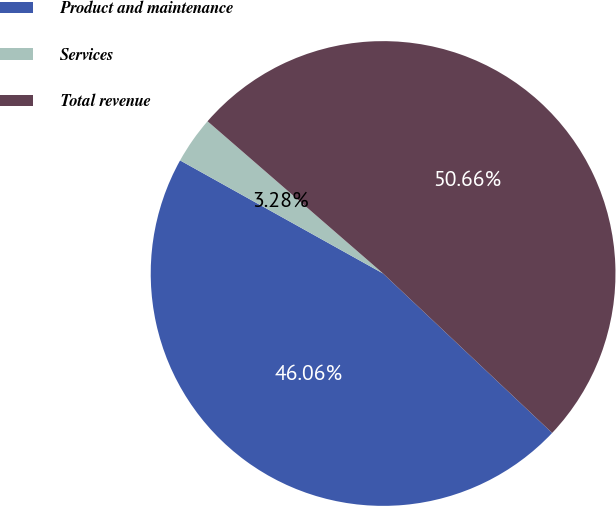Convert chart. <chart><loc_0><loc_0><loc_500><loc_500><pie_chart><fcel>Product and maintenance<fcel>Services<fcel>Total revenue<nl><fcel>46.06%<fcel>3.28%<fcel>50.67%<nl></chart> 